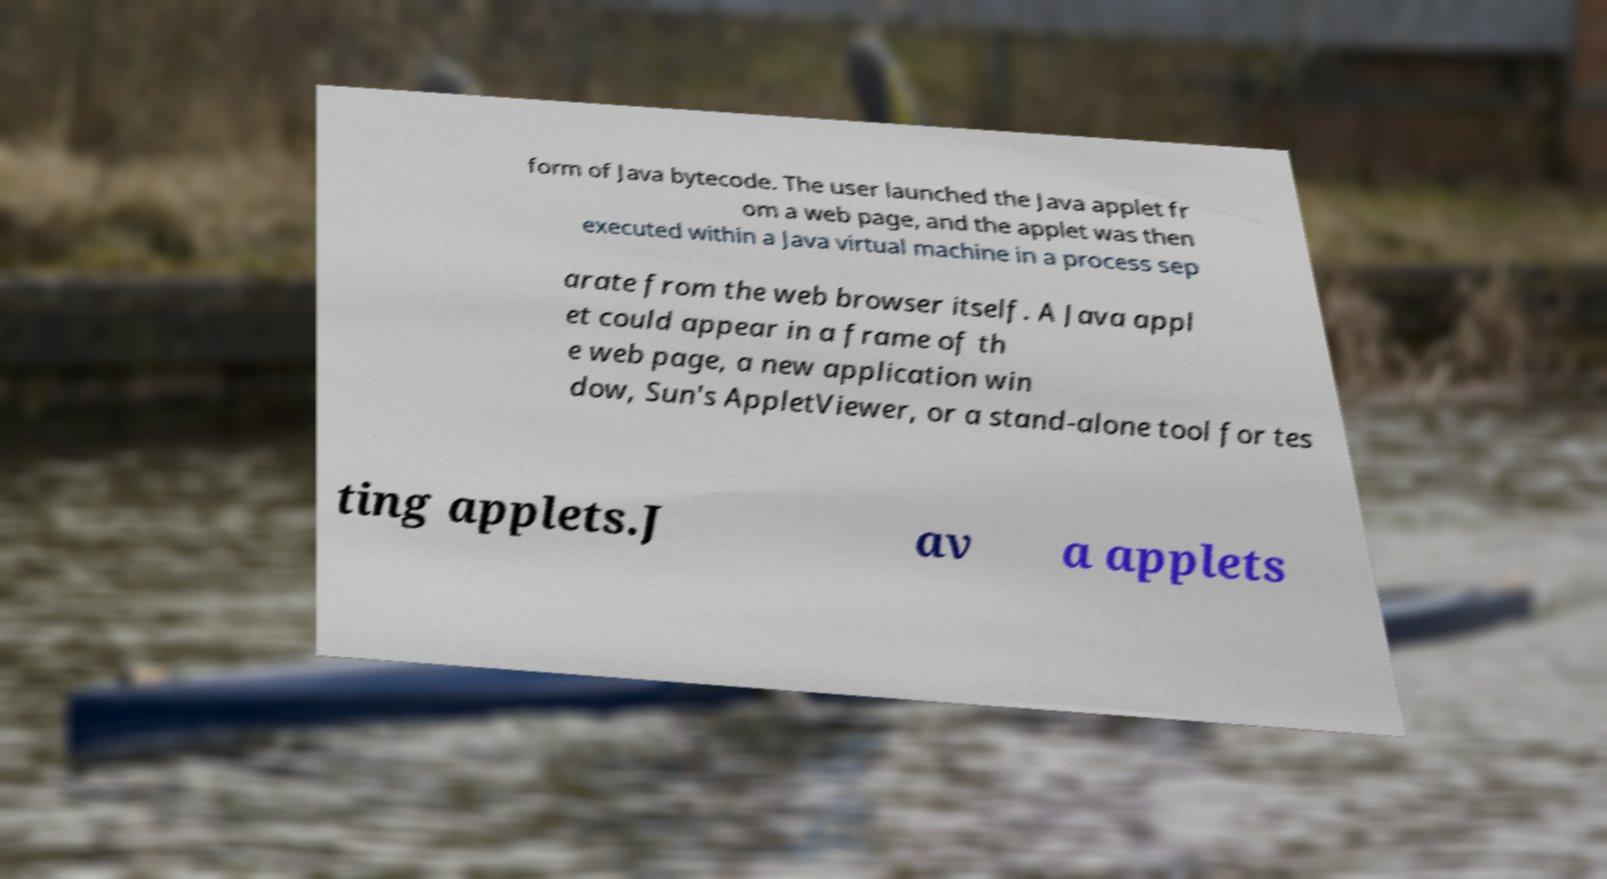Please identify and transcribe the text found in this image. form of Java bytecode. The user launched the Java applet fr om a web page, and the applet was then executed within a Java virtual machine in a process sep arate from the web browser itself. A Java appl et could appear in a frame of th e web page, a new application win dow, Sun's AppletViewer, or a stand-alone tool for tes ting applets.J av a applets 